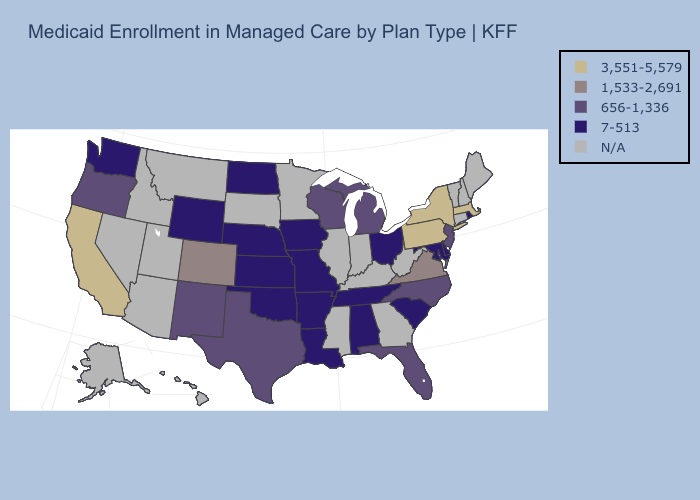What is the value of Virginia?
Quick response, please. 1,533-2,691. Which states have the highest value in the USA?
Short answer required. California, Massachusetts, New York, Pennsylvania. What is the value of Hawaii?
Short answer required. N/A. What is the lowest value in states that border Iowa?
Concise answer only. 7-513. Name the states that have a value in the range 7-513?
Short answer required. Alabama, Arkansas, Delaware, Iowa, Kansas, Louisiana, Maryland, Missouri, Nebraska, North Dakota, Ohio, Oklahoma, Rhode Island, South Carolina, Tennessee, Washington, Wyoming. Which states have the lowest value in the South?
Give a very brief answer. Alabama, Arkansas, Delaware, Louisiana, Maryland, Oklahoma, South Carolina, Tennessee. Name the states that have a value in the range N/A?
Keep it brief. Alaska, Arizona, Connecticut, Georgia, Hawaii, Idaho, Illinois, Indiana, Kentucky, Maine, Minnesota, Mississippi, Montana, Nevada, New Hampshire, South Dakota, Utah, Vermont, West Virginia. Name the states that have a value in the range 7-513?
Quick response, please. Alabama, Arkansas, Delaware, Iowa, Kansas, Louisiana, Maryland, Missouri, Nebraska, North Dakota, Ohio, Oklahoma, Rhode Island, South Carolina, Tennessee, Washington, Wyoming. What is the lowest value in states that border Pennsylvania?
Be succinct. 7-513. Among the states that border Minnesota , which have the lowest value?
Short answer required. Iowa, North Dakota. Does Virginia have the lowest value in the South?
Be succinct. No. Which states have the lowest value in the USA?
Answer briefly. Alabama, Arkansas, Delaware, Iowa, Kansas, Louisiana, Maryland, Missouri, Nebraska, North Dakota, Ohio, Oklahoma, Rhode Island, South Carolina, Tennessee, Washington, Wyoming. What is the value of South Carolina?
Give a very brief answer. 7-513. Does the first symbol in the legend represent the smallest category?
Answer briefly. No. 